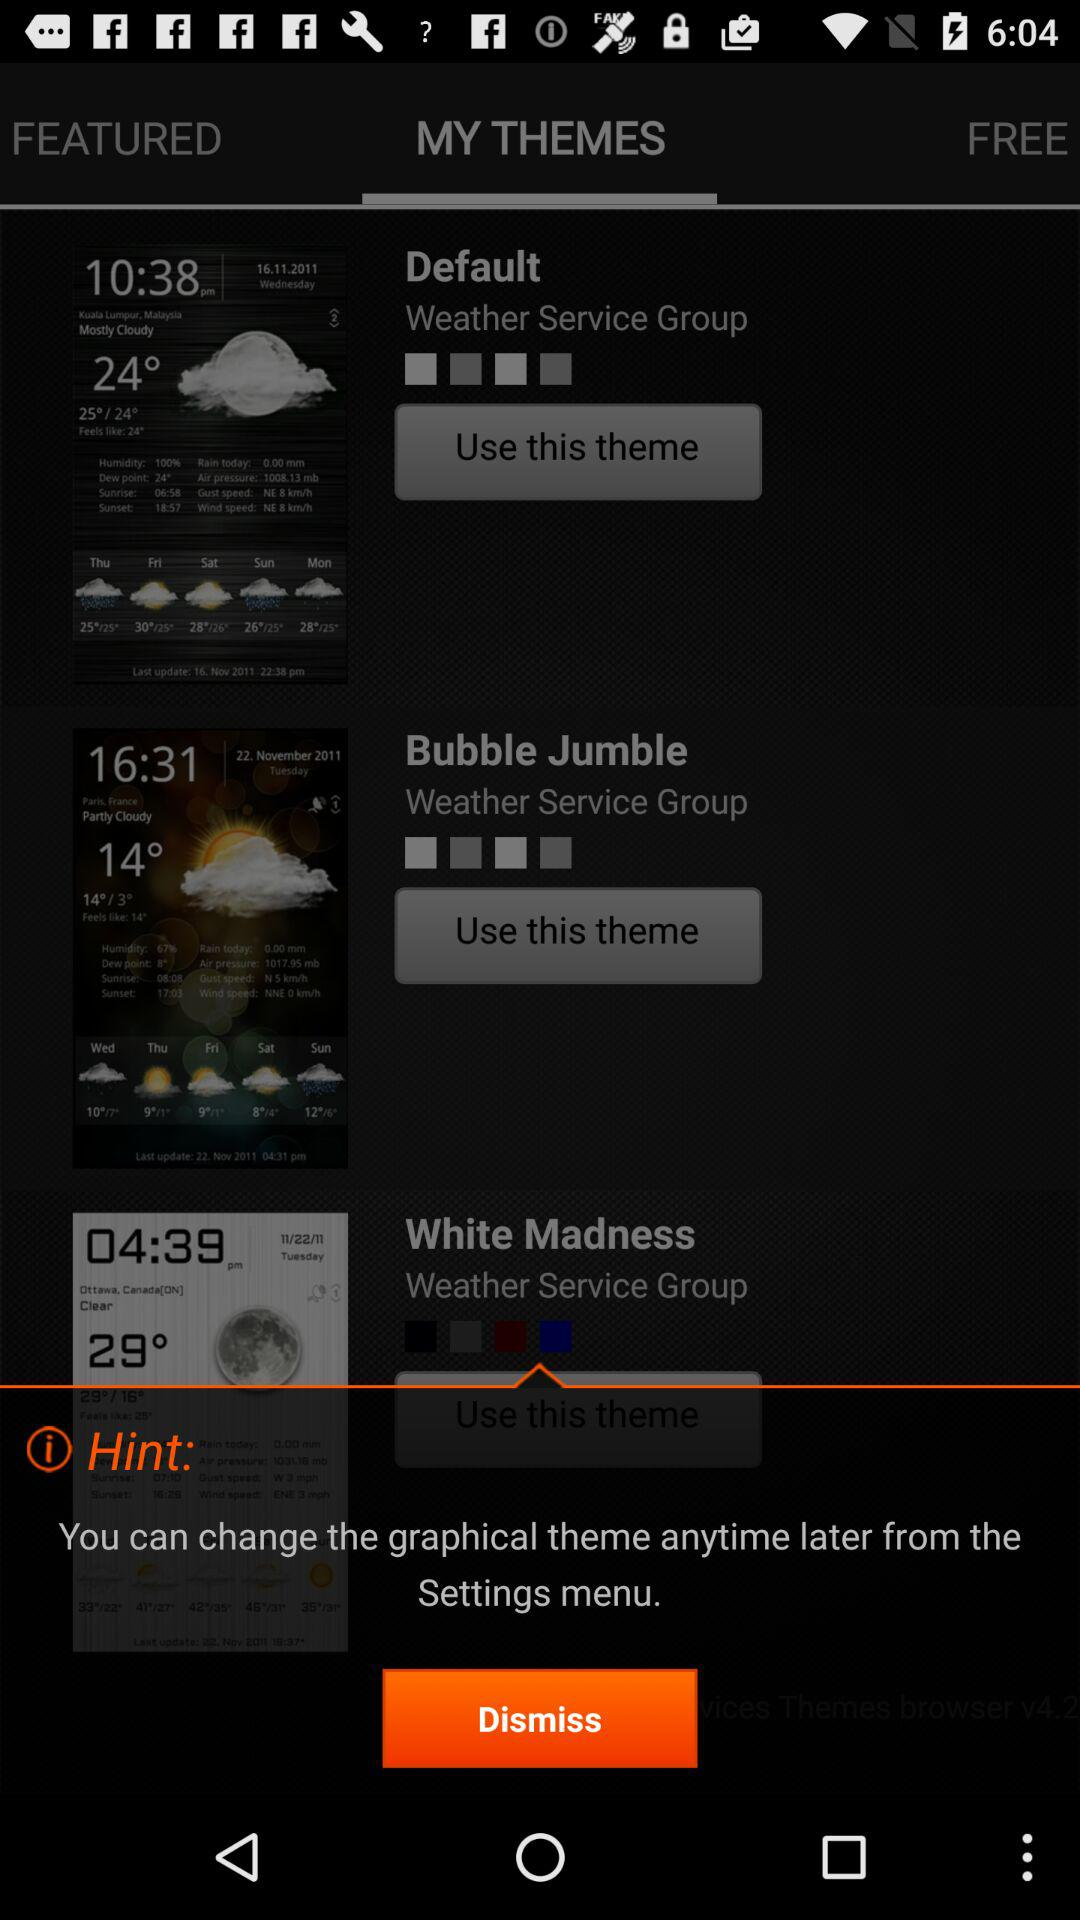Which tab is selected? The selected tab is "MY THEMES". 